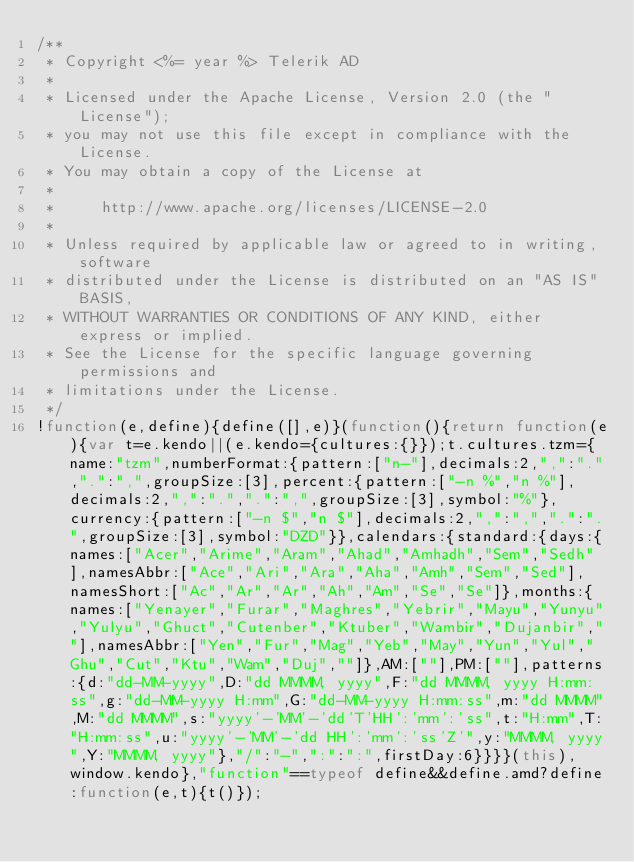Convert code to text. <code><loc_0><loc_0><loc_500><loc_500><_JavaScript_>/**
 * Copyright <%= year %> Telerik AD
 *
 * Licensed under the Apache License, Version 2.0 (the "License");
 * you may not use this file except in compliance with the License.
 * You may obtain a copy of the License at
 *
 *     http://www.apache.org/licenses/LICENSE-2.0
 *
 * Unless required by applicable law or agreed to in writing, software
 * distributed under the License is distributed on an "AS IS" BASIS,
 * WITHOUT WARRANTIES OR CONDITIONS OF ANY KIND, either express or implied.
 * See the License for the specific language governing permissions and
 * limitations under the License.
 */
!function(e,define){define([],e)}(function(){return function(e){var t=e.kendo||(e.kendo={cultures:{}});t.cultures.tzm={name:"tzm",numberFormat:{pattern:["n-"],decimals:2,",":".",".":",",groupSize:[3],percent:{pattern:["-n %","n %"],decimals:2,",":".",".":",",groupSize:[3],symbol:"%"},currency:{pattern:["-n $","n $"],decimals:2,",":",",".":".",groupSize:[3],symbol:"DZD"}},calendars:{standard:{days:{names:["Acer","Arime","Aram","Ahad","Amhadh","Sem","Sedh"],namesAbbr:["Ace","Ari","Ara","Aha","Amh","Sem","Sed"],namesShort:["Ac","Ar","Ar","Ah","Am","Se","Se"]},months:{names:["Yenayer","Furar","Maghres","Yebrir","Mayu","Yunyu","Yulyu","Ghuct","Cutenber","Ktuber","Wambir","Dujanbir",""],namesAbbr:["Yen","Fur","Mag","Yeb","May","Yun","Yul","Ghu","Cut","Ktu","Wam","Duj",""]},AM:[""],PM:[""],patterns:{d:"dd-MM-yyyy",D:"dd MMMM, yyyy",F:"dd MMMM, yyyy H:mm:ss",g:"dd-MM-yyyy H:mm",G:"dd-MM-yyyy H:mm:ss",m:"dd MMMM",M:"dd MMMM",s:"yyyy'-'MM'-'dd'T'HH':'mm':'ss",t:"H:mm",T:"H:mm:ss",u:"yyyy'-'MM'-'dd HH':'mm':'ss'Z'",y:"MMMM, yyyy",Y:"MMMM, yyyy"},"/":"-",":":":",firstDay:6}}}}(this),window.kendo},"function"==typeof define&&define.amd?define:function(e,t){t()});</code> 